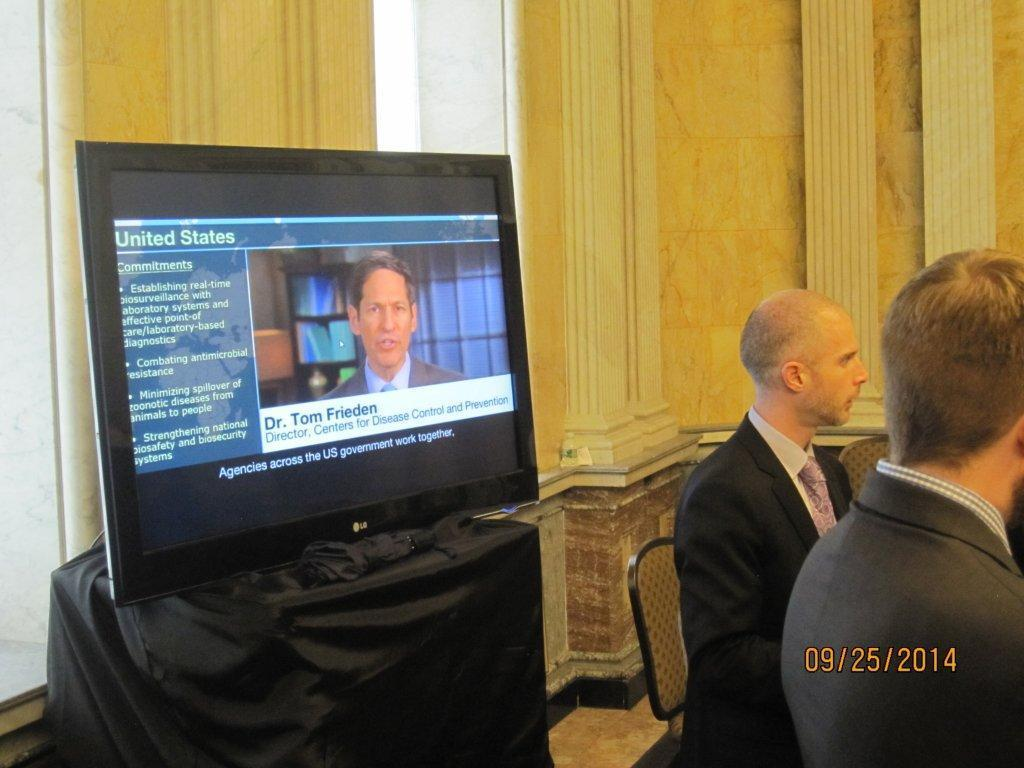<image>
Provide a brief description of the given image. Dr. Tom Frieden is on tv and he is the Director of the Centers for Disease Control and Prevention. 